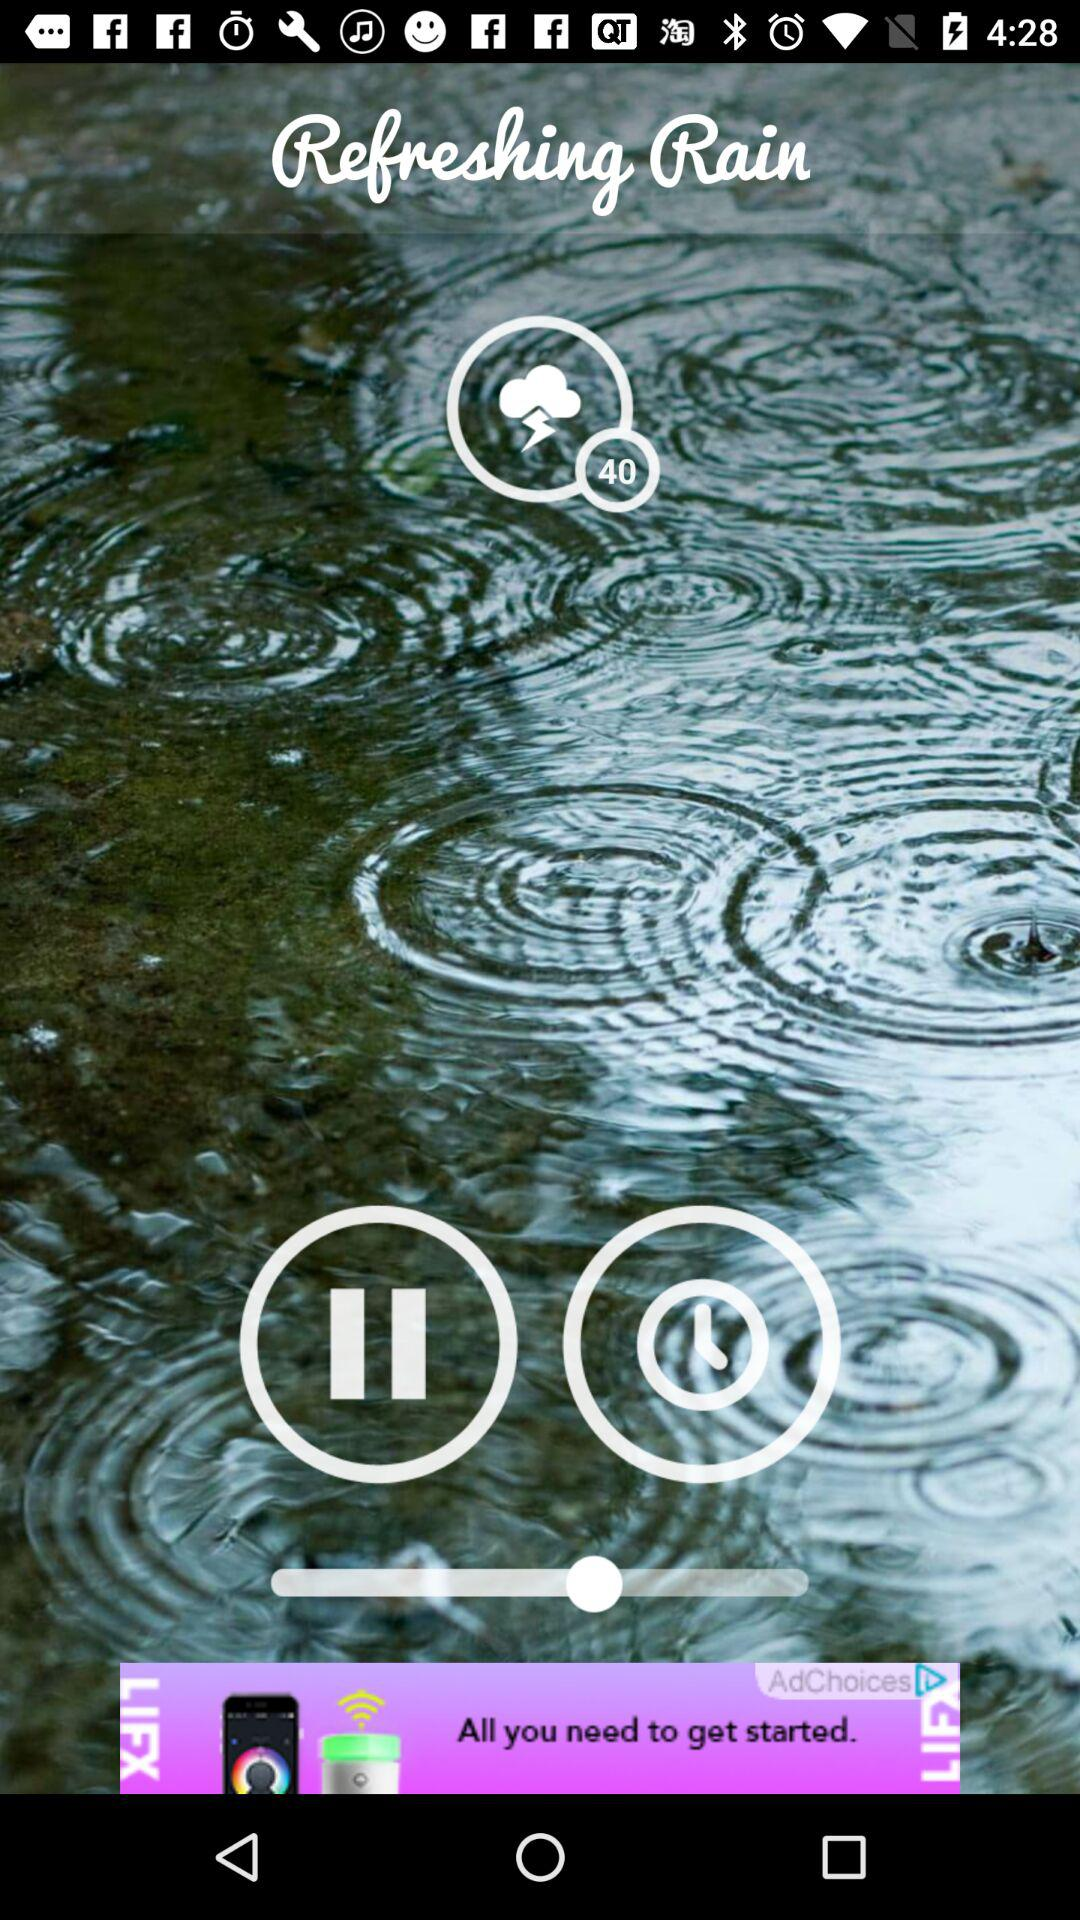What's the Refreshing Rain sound Duration?
When the provided information is insufficient, respond with <no answer>. <no answer> 